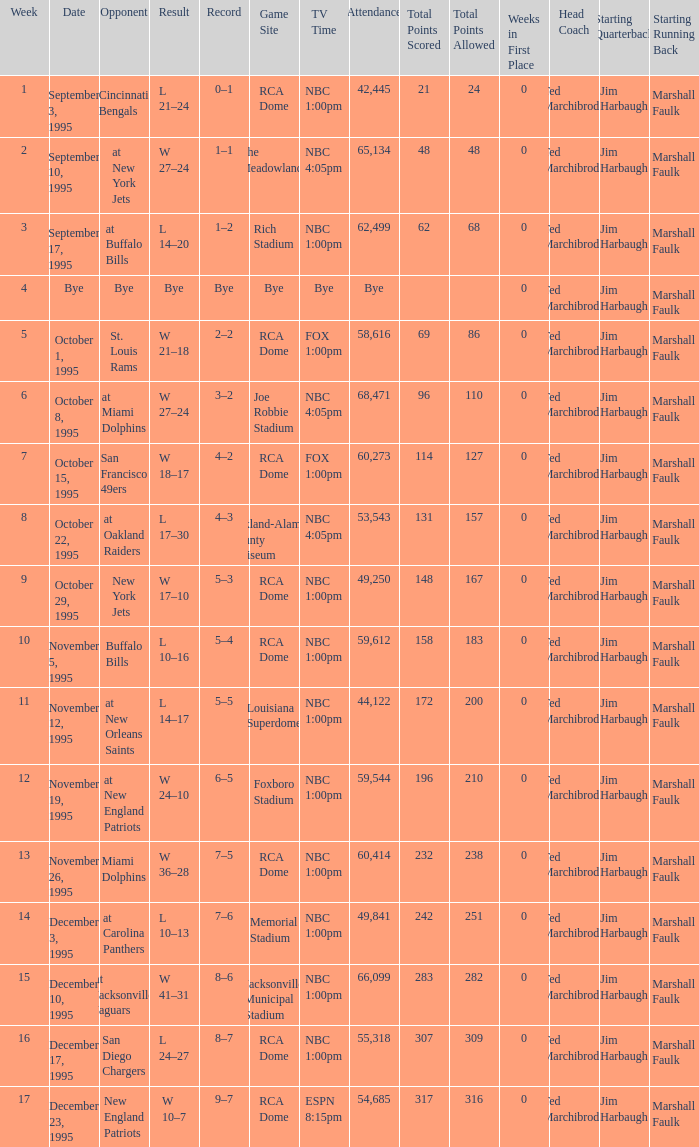What's the Game SIte with an Opponent of San Diego Chargers? RCA Dome. 